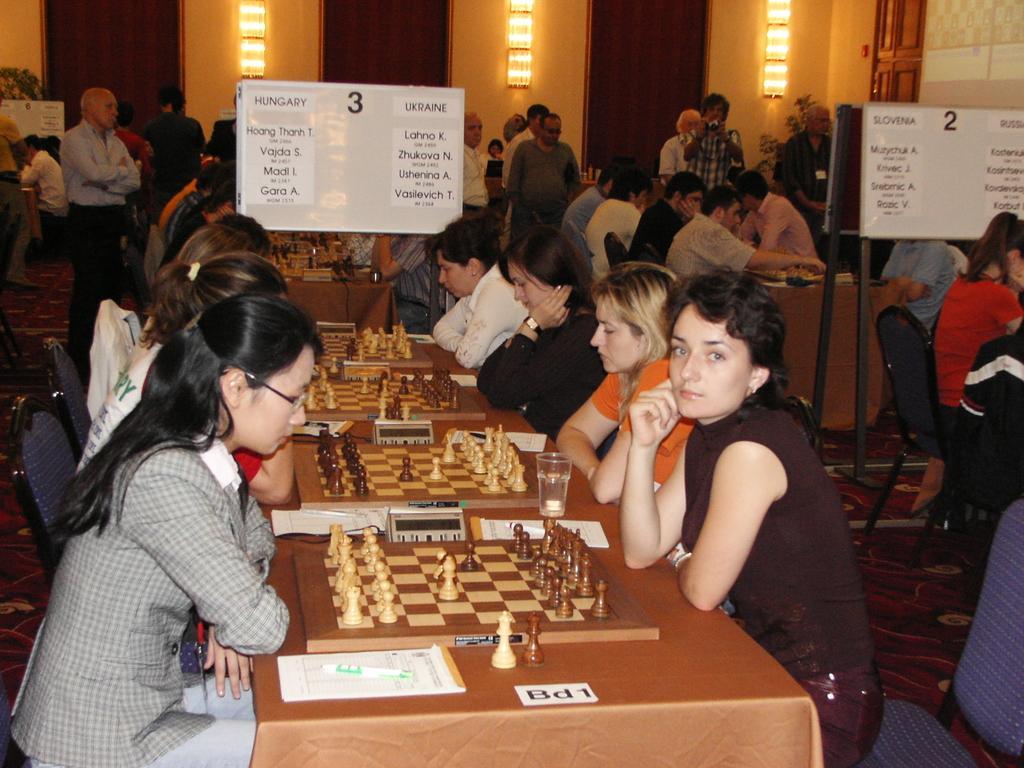How would you summarize this image in a sentence or two? Group of people are sitting on chairs and few people are standing. In middle of them there are tables and whiteboards. On this whiteboards there are posters. Lights on wall. On this table there is a glass, chess board, paper, pen and chess coins. Far a person is standing and holding a camera. 